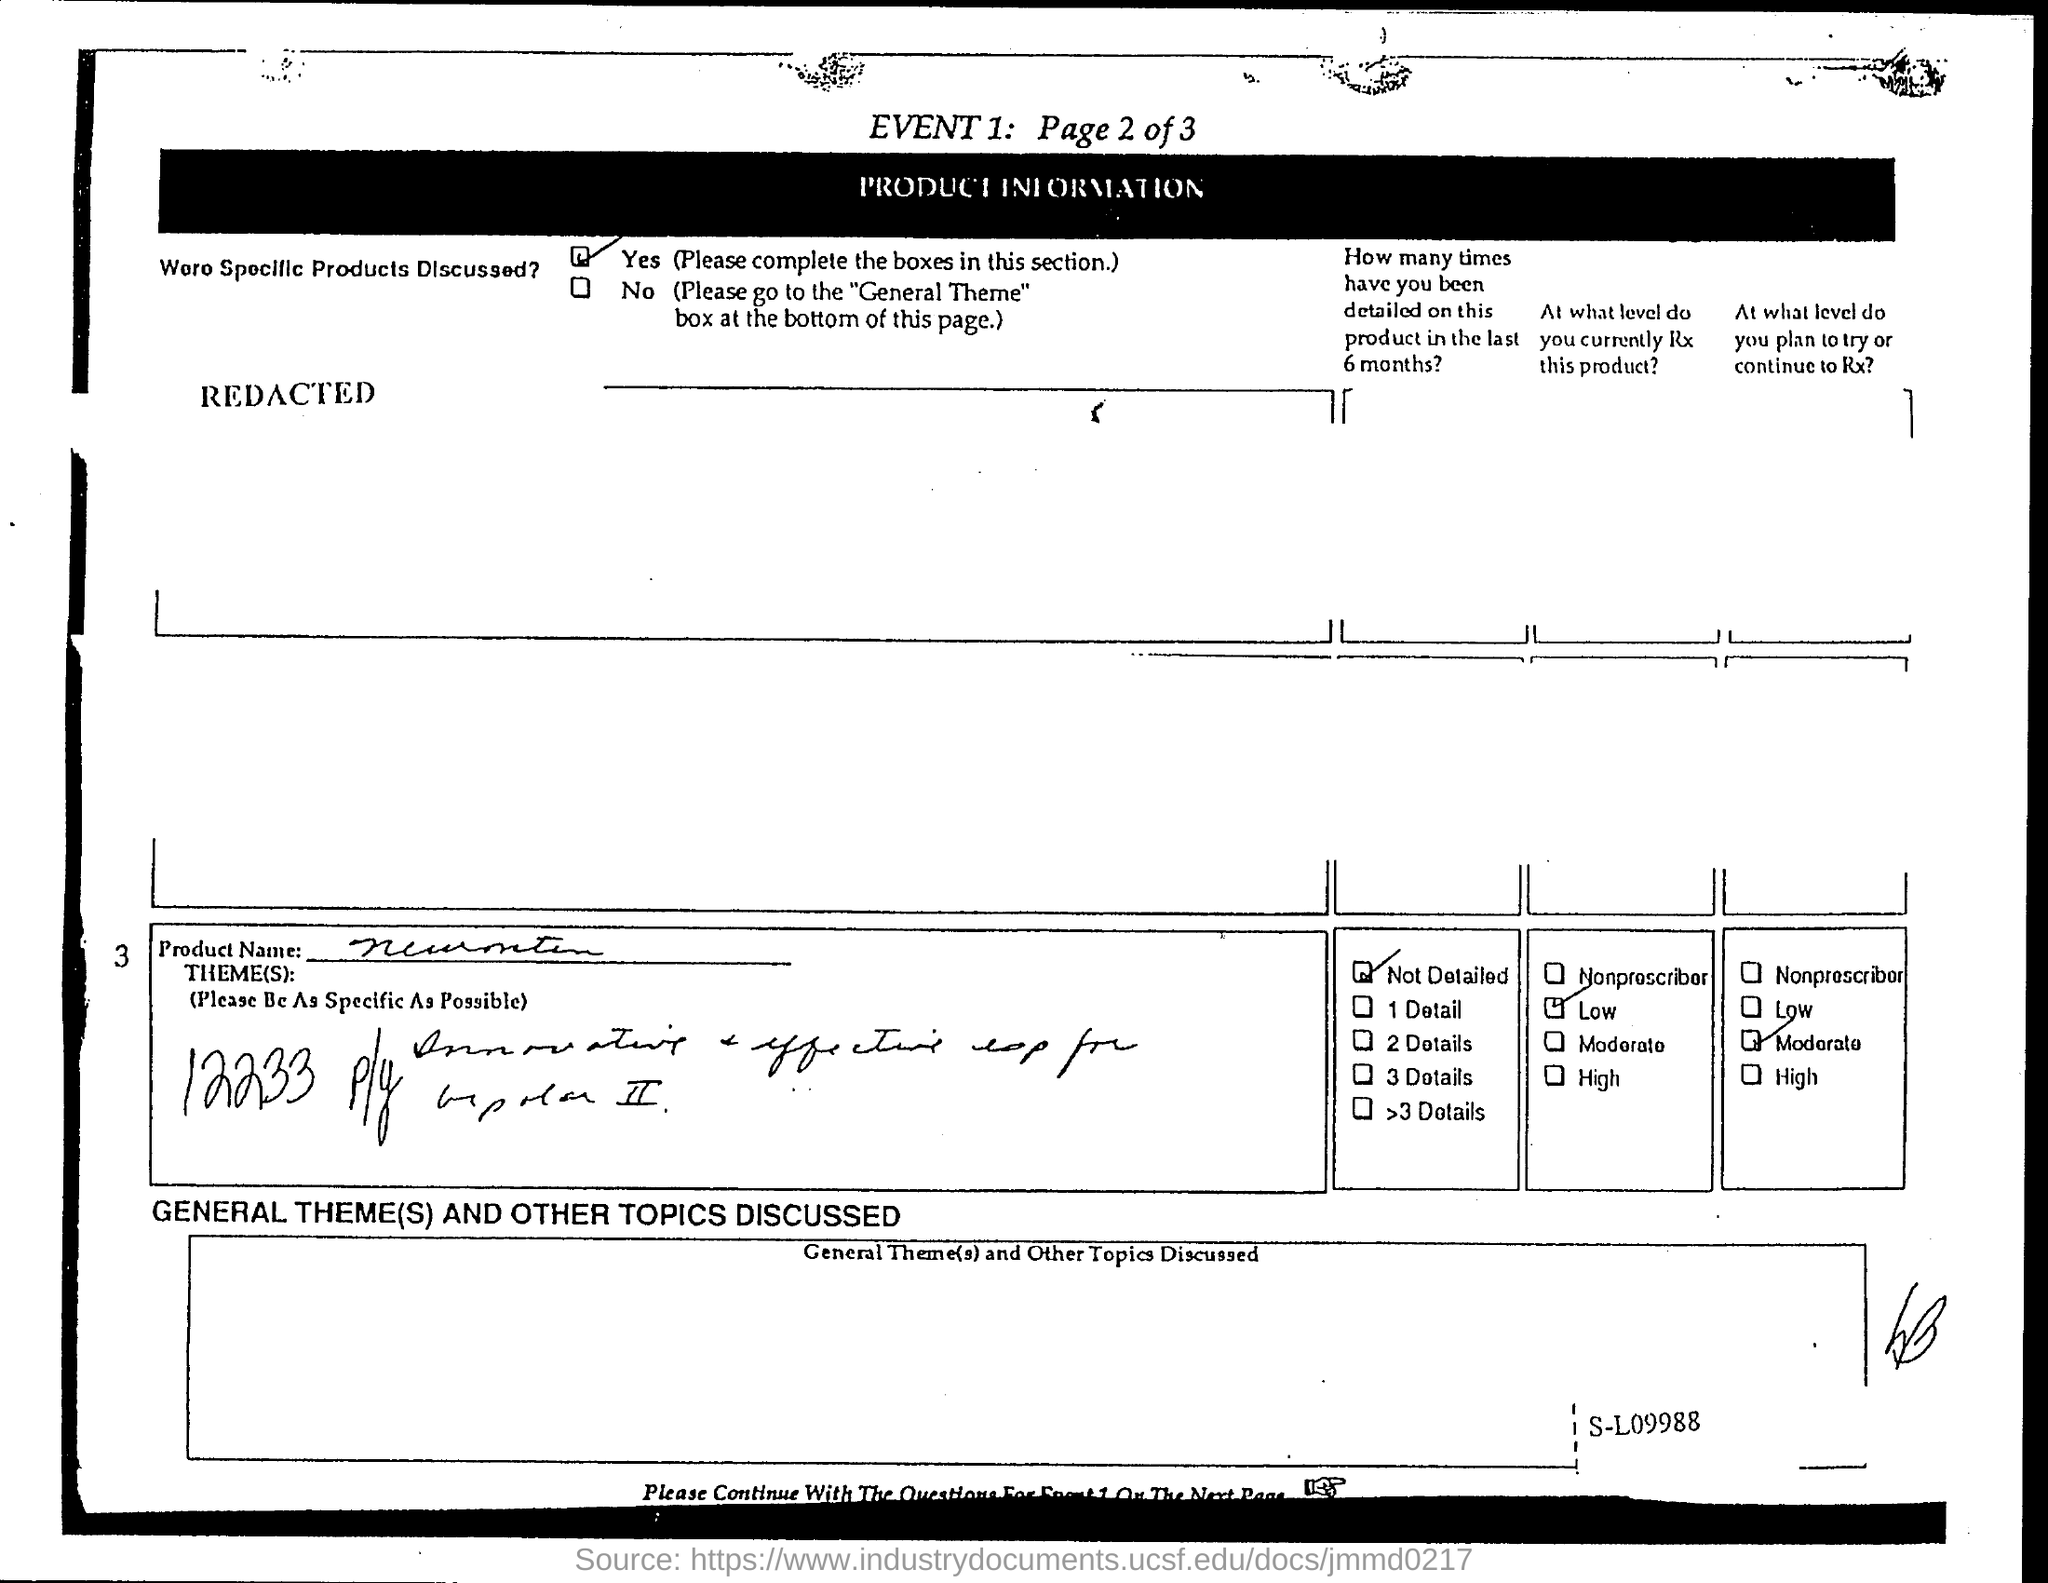Identify some key points in this picture. Yes, specific products were discussed during the meeting. 